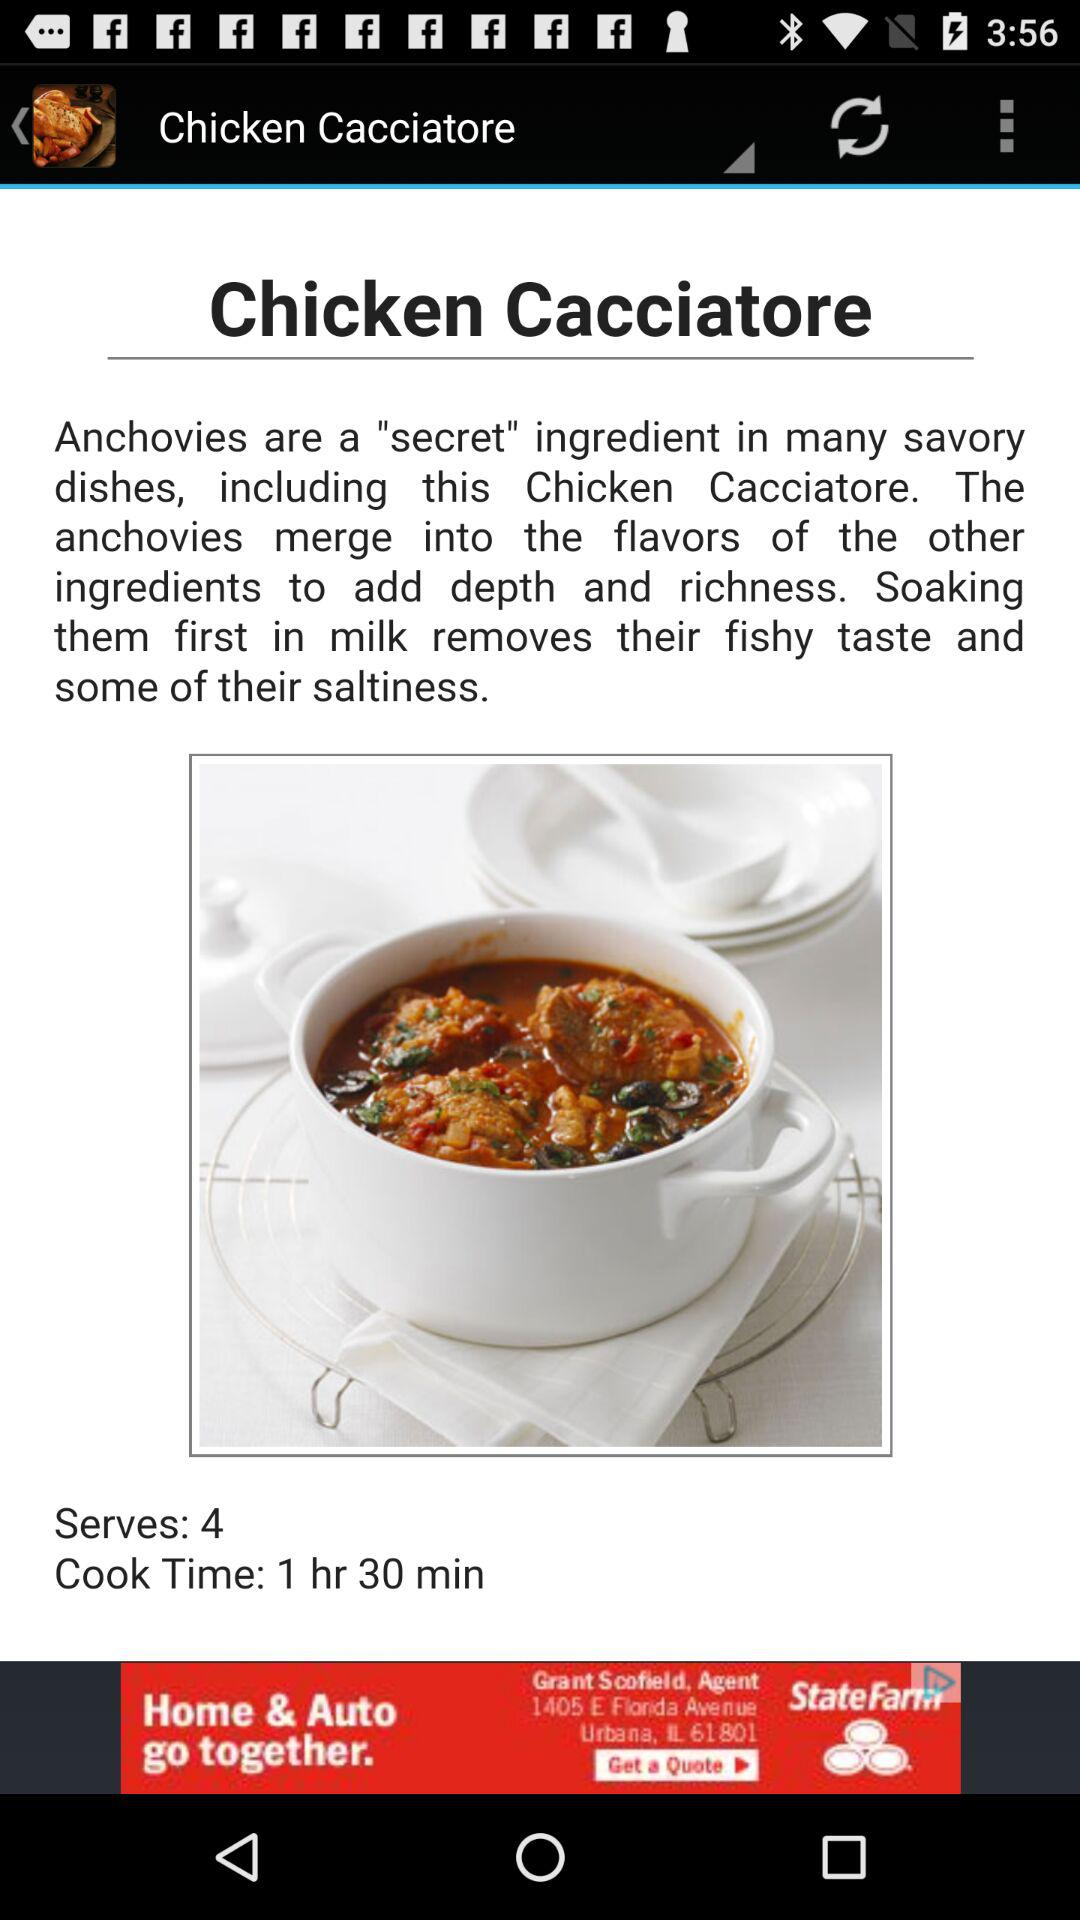What is the dish name? The dish name is "Chicken Cacciatore". 